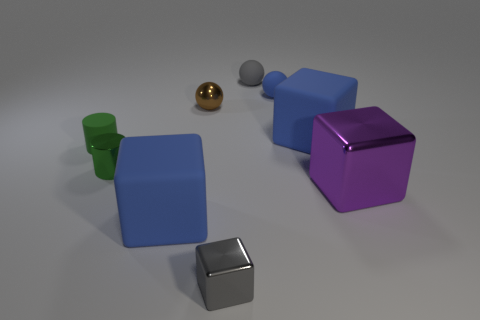Subtract all small rubber balls. How many balls are left? 1 Subtract all gray cylinders. How many blue cubes are left? 2 Subtract all purple cubes. How many cubes are left? 3 Subtract 1 spheres. How many spheres are left? 2 Add 1 tiny green cylinders. How many objects exist? 10 Subtract all brown blocks. Subtract all green cylinders. How many blocks are left? 4 Add 7 big brown rubber balls. How many big brown rubber balls exist? 7 Subtract 0 gray cylinders. How many objects are left? 9 Subtract all blocks. How many objects are left? 5 Subtract all blue spheres. Subtract all large brown rubber cubes. How many objects are left? 8 